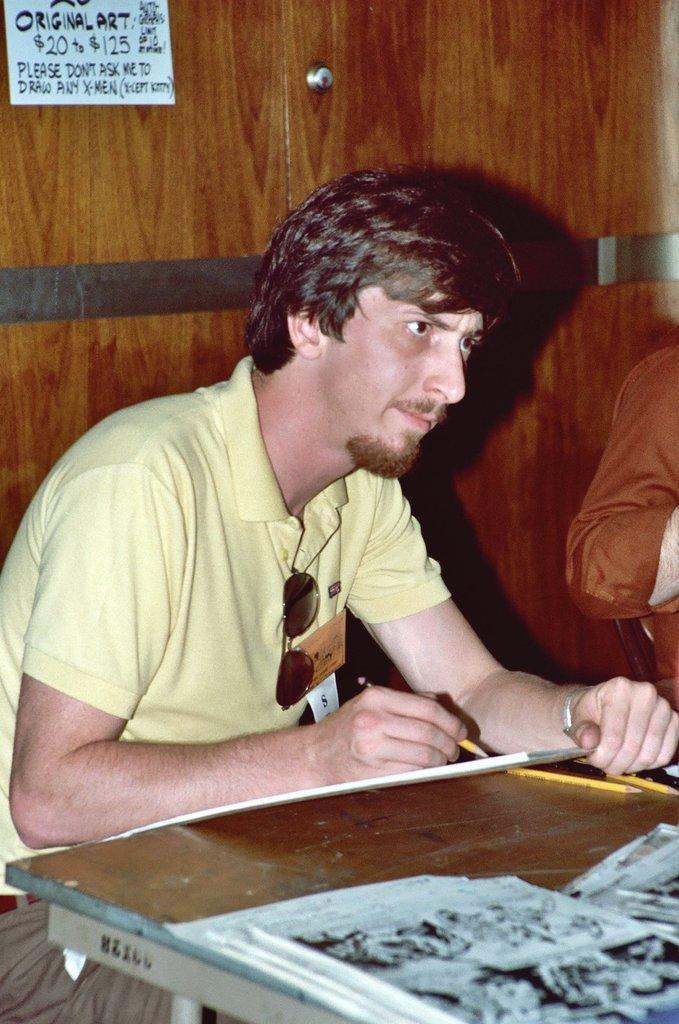How would you summarize this image in a sentence or two? In this image we can see a person is sitting. He is wearing yellow color t-shirt and holding pen and sheet in his hand. In front of him one brown color table is there. On table papers are present. Background one cupboard is present. Right side of the image one more person is there. 